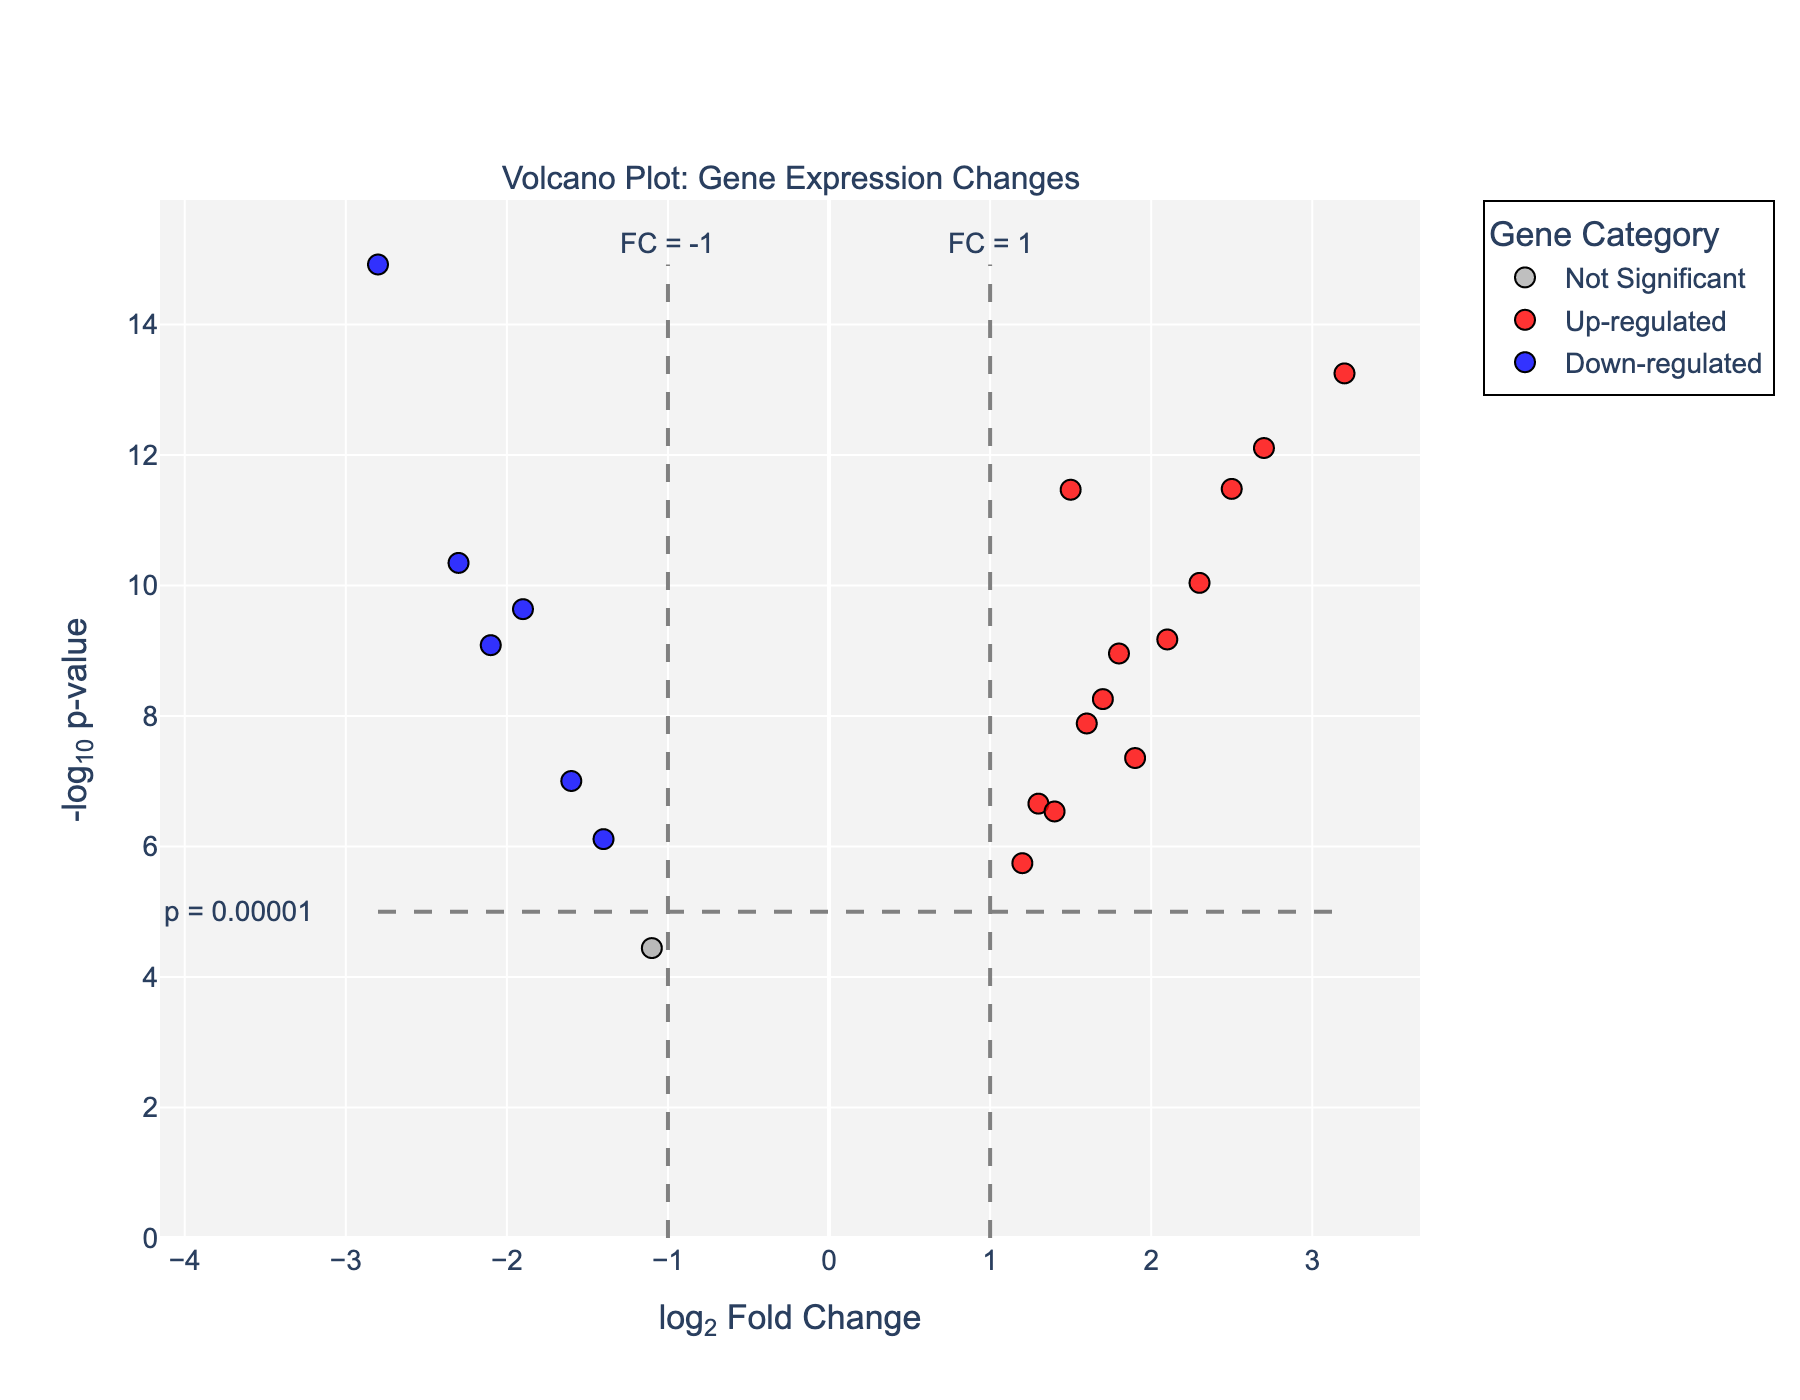What's the title of the plot? The title is located at the top of the plot. By reading the text at the top, we can see it says "Volcano Plot: Gene Expression Changes".
Answer: Volcano Plot: Gene Expression Changes What are the labels of the x-axis and y-axis? The x-axis and y-axis labels are found next to their respective axes. The x-axis is labeled "log2 Fold Change" and the y-axis is labeled "-log10 p-value".
Answer: log2 Fold Change; -log10 p-value How many genes are classified as "Up-regulated"? To find the number of "Up-regulated" genes, we count the data points colored in red, as defined by the color scale.
Answer: 9 Which gene has the highest log2 fold change? By observing the x-axis for the highest value and locating the data point, we see that MYC has the highest log2 fold change value of 3.2.
Answer: MYC Which genes are classified as "Down-regulated"? We look for the genes in the blue color category, indicating significant down-regulation. The listed genes are TP53, PTEN, CDKN2A, BCL2, CDH1, and JAK2.
Answer: TP53, PTEN, CDKN2A, BCL2, CDH1, JAK2 What is the significance threshold for the p-value? This threshold is shown on the y-axis annotation and the gray dashed line, indicating the threshold at log10(p-value) = 5. This corresponds to a p-value of 0.00001.
Answer: 0.00001 Compare the -log10 p-value of TP53 and MYC. Which gene has a higher value? TP53 has a -log10 p-value of approximately 15, while MYC has a -log10 p-value of approximately 14. Therefore, TP53 has a higher -log10 p-value.
Answer: TP53 What color is used to represent non-significant genes? Reference the color scale to see that "Not Significant" genes are colored in grey.
Answer: Grey Explain why the point representing the MYC gene is placed at the top right region of the plot. The MYC gene has among the highest values for both log2 fold change (x-axis) and -log10 p-value (y-axis), placing it in the top right. High log2 fold change indicates strong up-regulation, and high -log10 p-value indicates statistical significance.
Answer: High log2 fold change and high -log10 p-value How are the threshold lines for fold change marked on the plot? The threshold for fold change is marked by vertical dashed lines at x = 1 and x = -1. Annotations next to these lines confirm their exact values.
Answer: x = 1 and x = -1 